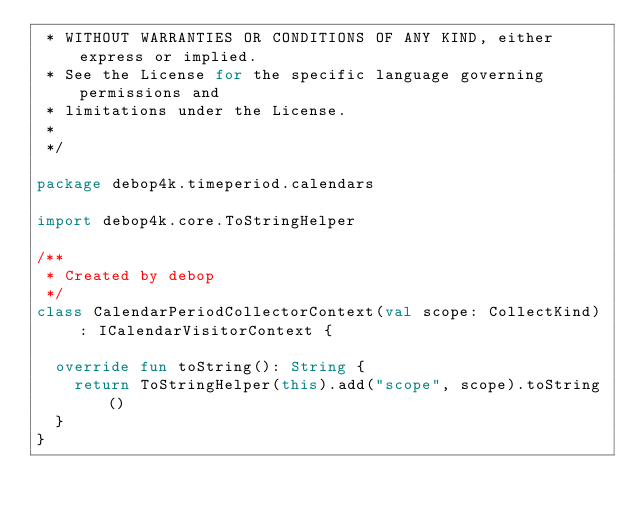<code> <loc_0><loc_0><loc_500><loc_500><_Kotlin_> * WITHOUT WARRANTIES OR CONDITIONS OF ANY KIND, either express or implied.
 * See the License for the specific language governing permissions and
 * limitations under the License.
 *
 */

package debop4k.timeperiod.calendars

import debop4k.core.ToStringHelper

/**
 * Created by debop
 */
class CalendarPeriodCollectorContext(val scope: CollectKind) : ICalendarVisitorContext {

  override fun toString(): String {
    return ToStringHelper(this).add("scope", scope).toString()
  }
}</code> 